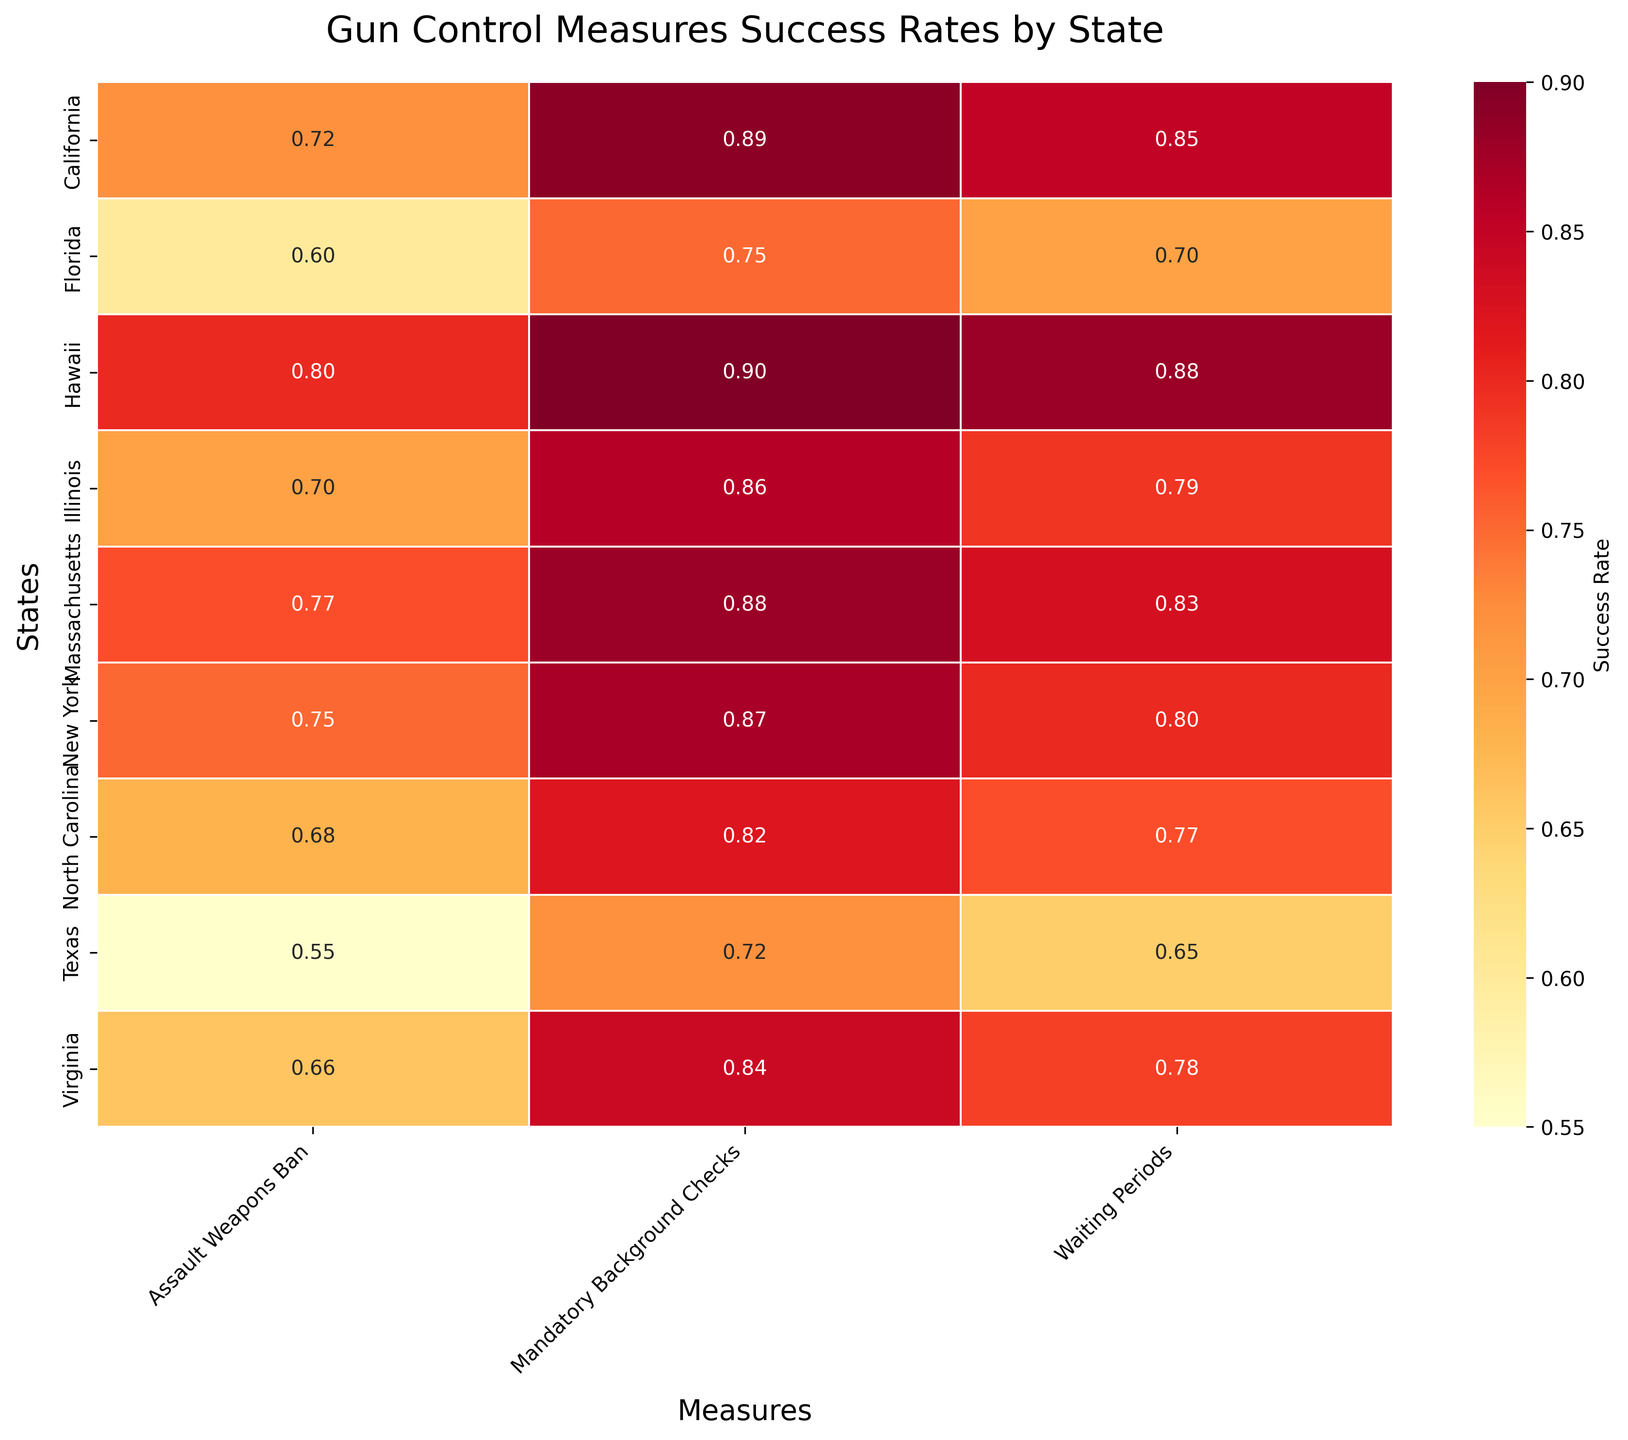What is the success rate of mandatory background checks in Virginia? Look for the intersection of "Virginia" and "Mandatory Background Checks" on the heatmap.
Answer: 0.84 Which state has the highest success rate for assault weapons bans? Compare the values of the "Assault Weapons Ban" column across all states. The highest value is in Hawaii.
Answer: Hawaii What is the average success rate of waiting periods across all states? Sum the success rates of "Waiting Periods" for all states and divide by the number of states. (0.85+0.80+0.78+0.83+0.79+0.65+0.70+0.88+0.77)/9 = 6.25/9 = 0.69
Answer: 0.69 How does the success rate of waiting periods in Florida compare to that in Texas? Look at the success rates of "Waiting Periods" in Florida and Texas. Florida has 0.70, Texas has 0.65, so Florida is higher.
Answer: Florida is higher Which measure in California has the lowest success rate? Compare the success rates of all measures in California. The lowest rate is for "Assault Weapons Ban" which is 0.72.
Answer: Assault Weapons Ban Is the success rate of mandatory background checks in Hawaii higher than in California? Compare the values of "Mandatory Background Checks" in Hawaii (0.90) and California (0.89).
Answer: Yes Which state has the lowest success rate for waiting periods? Compare the values of "Waiting Periods" across all states. The lowest value is in Texas with 0.65.
Answer: Texas What is the difference in success rates between mandatory background checks and assault weapons ban in Massachusetts? Subtract the success rate of "Assault Weapons Ban" from that of "Mandatory Background Checks" in Massachusetts. 0.88 - 0.77 = 0.11
Answer: 0.11 What is the overall trend of success rates for gun control measures across all states? Look for general patterns in the heatmap, observing which measures tend to have higher or lower success rates across states. Generally, mandatory background checks have higher success rates.
Answer: Mandatory background checks tend to have higher success rates How many states have a success rate of 0.8 or higher for waiting periods? Count the states where the "Waiting Periods" measure has a success rate of 0.8 or higher. California, New York, Massachusetts, Hawaii,  and Illinois all meet this criterion.
Answer: 5 